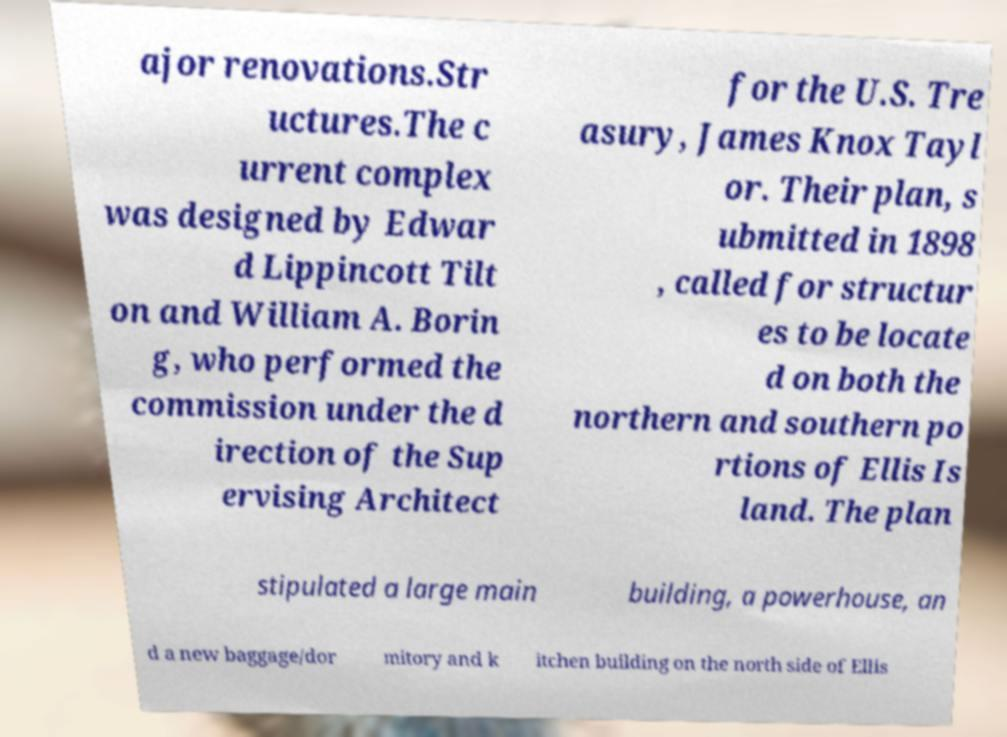I need the written content from this picture converted into text. Can you do that? ajor renovations.Str uctures.The c urrent complex was designed by Edwar d Lippincott Tilt on and William A. Borin g, who performed the commission under the d irection of the Sup ervising Architect for the U.S. Tre asury, James Knox Tayl or. Their plan, s ubmitted in 1898 , called for structur es to be locate d on both the northern and southern po rtions of Ellis Is land. The plan stipulated a large main building, a powerhouse, an d a new baggage/dor mitory and k itchen building on the north side of Ellis 